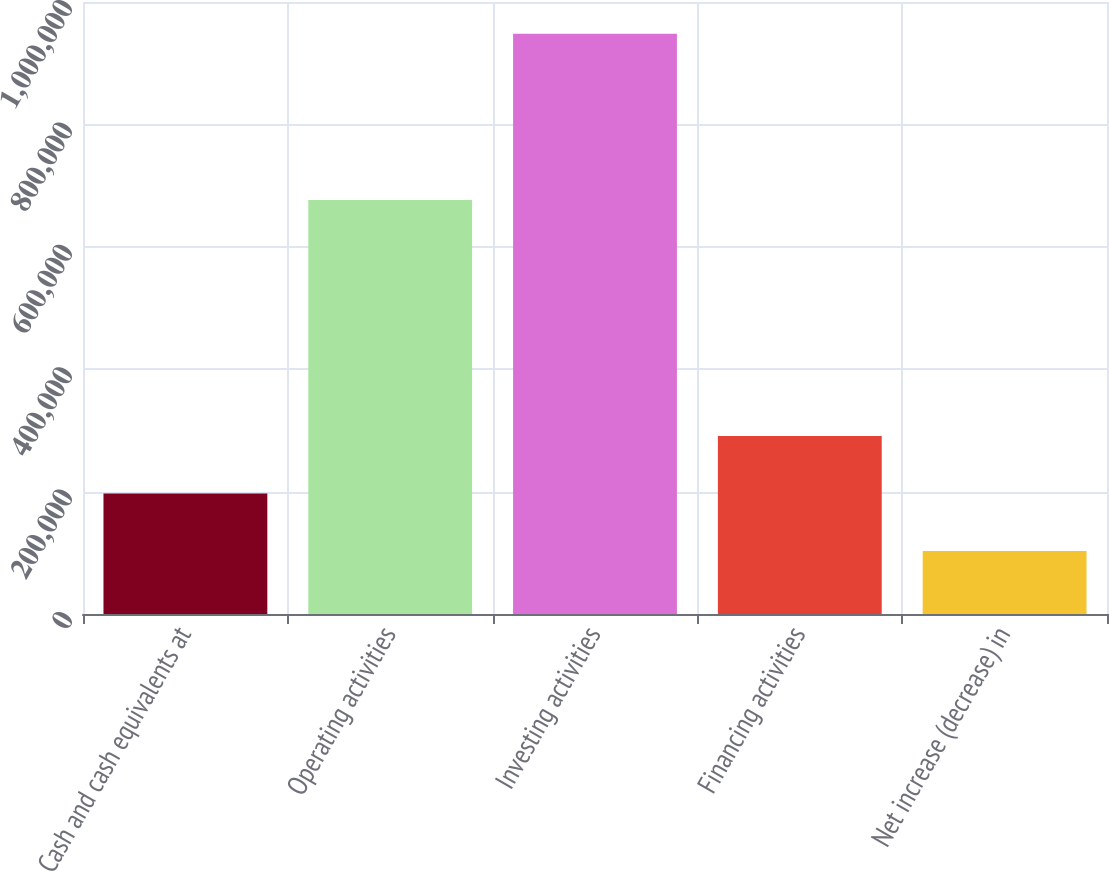<chart> <loc_0><loc_0><loc_500><loc_500><bar_chart><fcel>Cash and cash equivalents at<fcel>Operating activities<fcel>Investing activities<fcel>Financing activities<fcel>Net increase (decrease) in<nl><fcel>196907<fcel>676511<fcel>947995<fcel>290793<fcel>103021<nl></chart> 